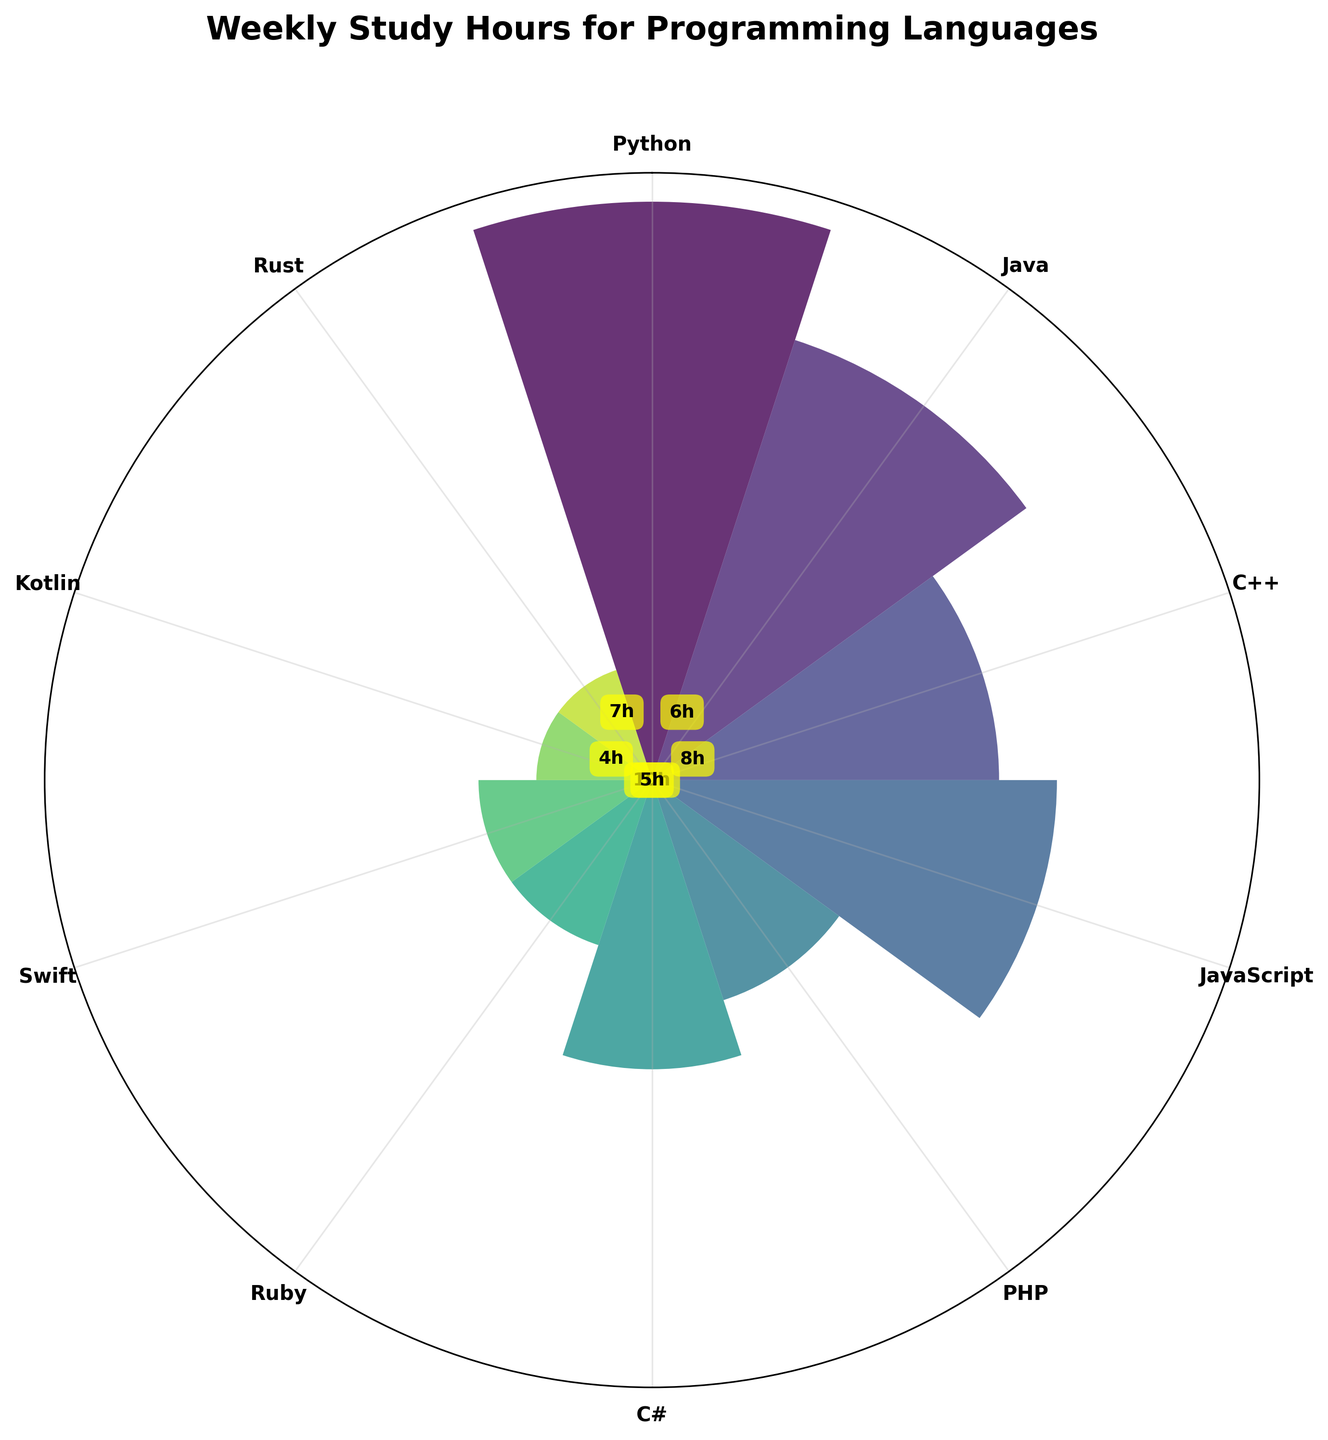What is the title of the chart? The chart's title is located at the top and reads, "Weekly Study Hours for Programming Languages"
Answer: Weekly Study Hours for Programming Languages How many programming languages are visualized in the chart? Count the number of labeled ticks around the polar plot. There are 10 labels for the programming languages
Answer: 10 What programming language has the highest weekly study hours? By observing the heights of the bars on the polar plot, the bar for Python extends the farthest from the center. Python has the highest weekly study hours at 10 hours
Answer: Python Which programming languages have the same weekly study hours? Identify bars of equal height. Ruby and Swift both have bars extending to the same radius, indicating 3 hours each. Kotlin and Rust also share the same radius for 2 hours each
Answer: Ruby and Swift, Kotlin and Rust How many total weekly study hours are spent on JavaScript and Java combined? JavaScript has 7 hours and Java has 8 hours. Adding these together gives 7 + 8 = 15
Answer: 15 Which programming language has 5 weekly study hours, and is it greater than or less than JavaScript's weekly study hours? Identify the bar for 5 hours, which corresponds to C#. Compare this to JavaScript’s bar, which is 7 hours. C# has lesser hours than JavaScript
Answer: C# and less than What is the average weekly study hours for Python, Java, and C++? Sum the weekly hours for Python (10), Java (8), and C++ (6) which results in 10 + 8 + 6 = 24. Divide by 3 to find the average, 24 / 3 = 8
Answer: 8 Which programming language has half the weekly study hours of Python? Python has 10 hours. Identify languages with 5 hours by dividing Python's hours by 2 (10/2). The corresponding bar for 5 hours belongs to C#
Answer: C# What is the mid-range of the weekly study hours for the programming languages displayed in the chart? Mid-range is the average of the maximum and minimum values. Maximum value: Python (10 hours), Minimum value: Kotlin and Rust (2 hours). Sum these values (10 + 2 = 12) and divide by 2 to find the mid-range, 12 / 2 = 6
Answer: 6 